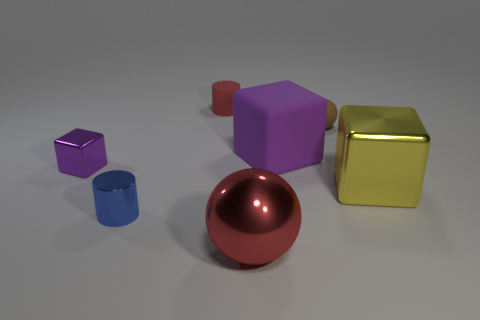Add 3 tiny purple metallic blocks. How many objects exist? 10 Subtract all big purple rubber blocks. How many blocks are left? 2 Subtract all yellow cubes. How many cubes are left? 2 Subtract all blocks. How many objects are left? 4 Subtract all purple cylinders. How many purple blocks are left? 2 Add 2 small blue shiny cylinders. How many small blue shiny cylinders are left? 3 Add 7 cyan shiny cylinders. How many cyan shiny cylinders exist? 7 Subtract 0 gray balls. How many objects are left? 7 Subtract all red balls. Subtract all red cubes. How many balls are left? 1 Subtract all big spheres. Subtract all tiny things. How many objects are left? 2 